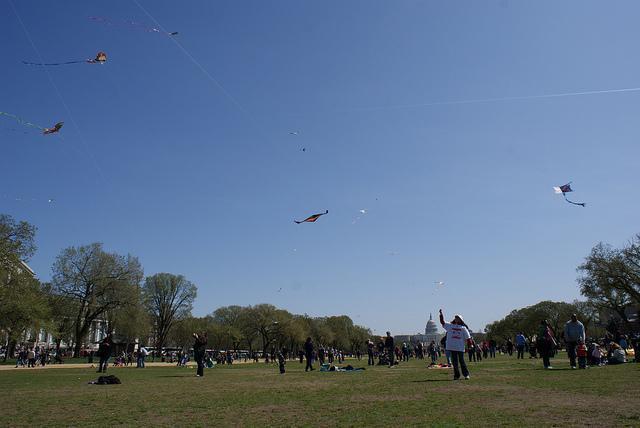How many yellow cups are in the image?
Give a very brief answer. 0. 